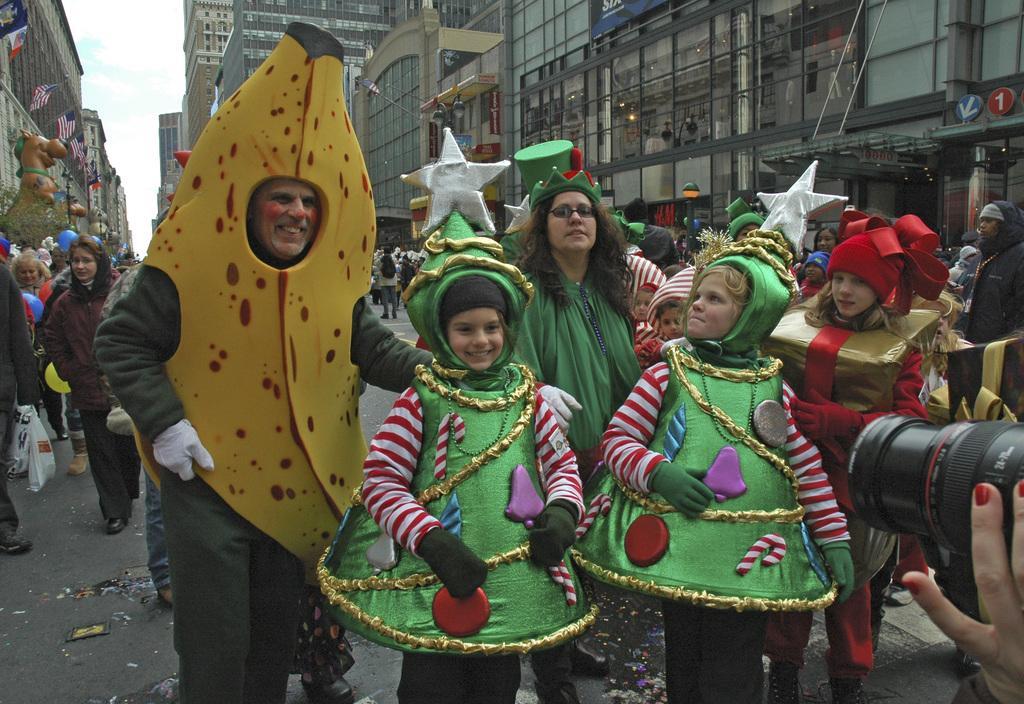Please provide a concise description of this image. In this image there are people on the road. In the background of the image there are buildings, flags and sky. 